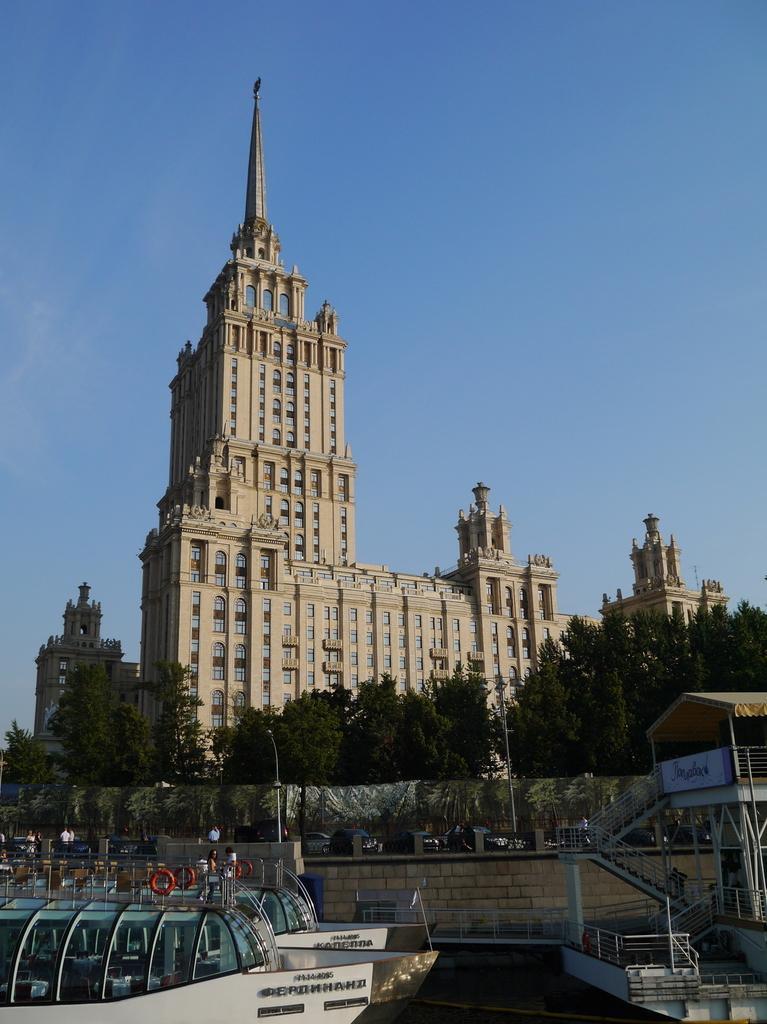Could you give a brief overview of what you see in this image? In this image we can see boats, staircase, board, poles, vehicles, wall, and people. In the background there are trees, buildings, and sky. 